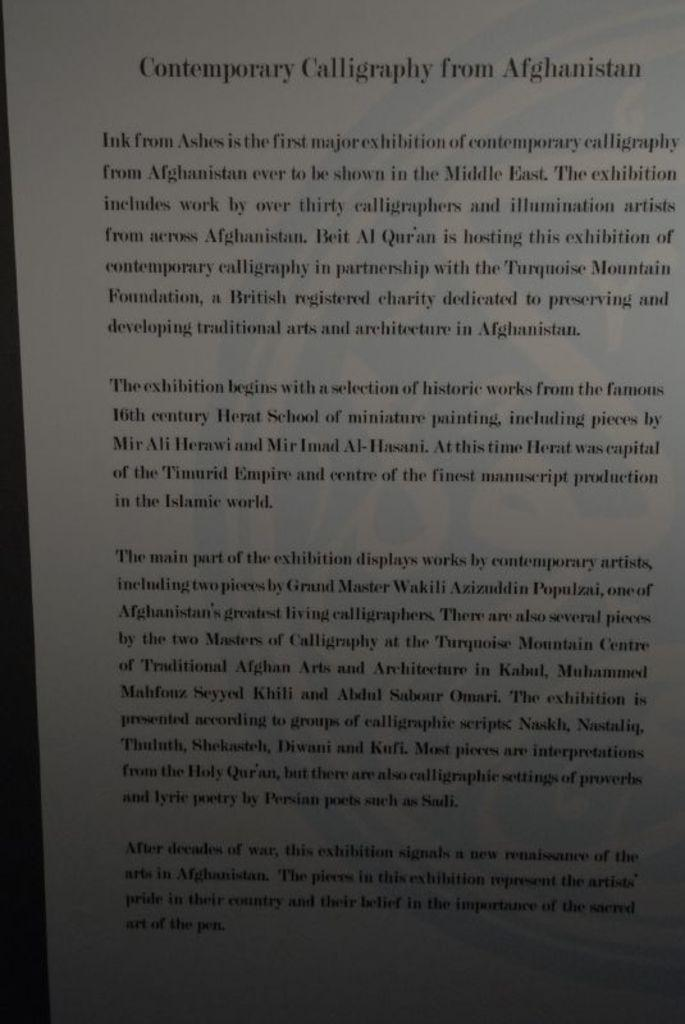<image>
Render a clear and concise summary of the photo. A textbook open to a page with the title Contemporary Calligraphy. 